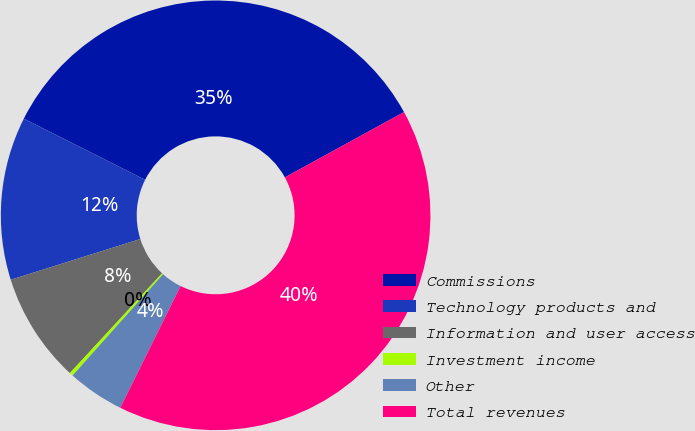Convert chart. <chart><loc_0><loc_0><loc_500><loc_500><pie_chart><fcel>Commissions<fcel>Technology products and<fcel>Information and user access<fcel>Investment income<fcel>Other<fcel>Total revenues<nl><fcel>34.59%<fcel>12.28%<fcel>8.28%<fcel>0.27%<fcel>4.28%<fcel>40.3%<nl></chart> 